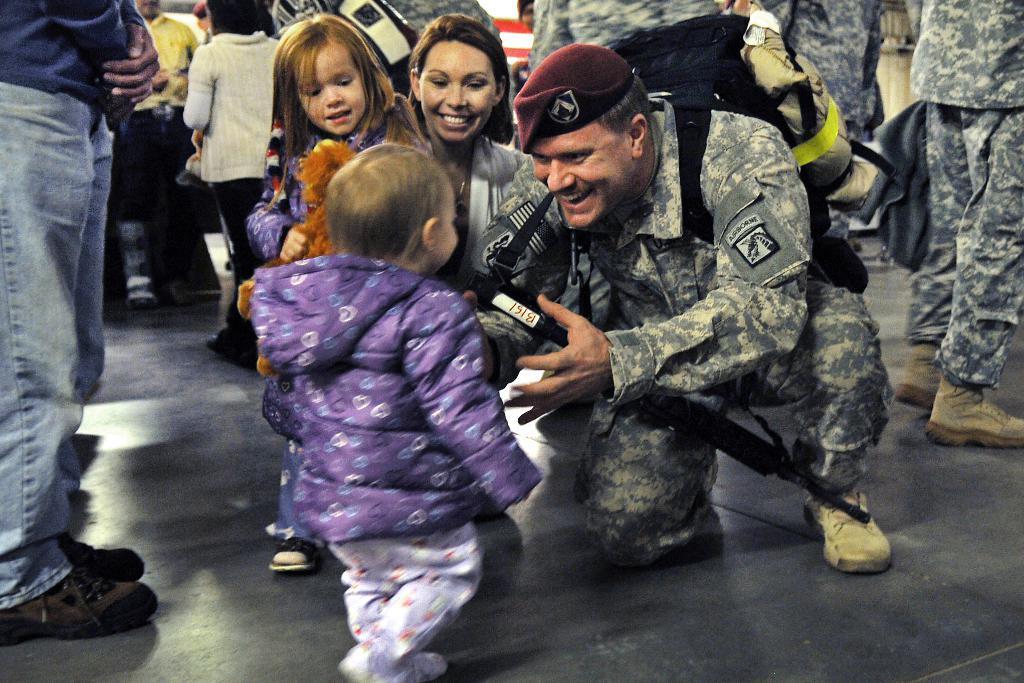Please provide a concise description of this image. Here I can see a man wearing uniform, sitting on the knees and smiling by looking at the baby who is in front of him. Beside this man there is a woman and a girl are also smiling by looking at this baby. In the background, I can see few people are standing on the floor. Few are holding bags. 